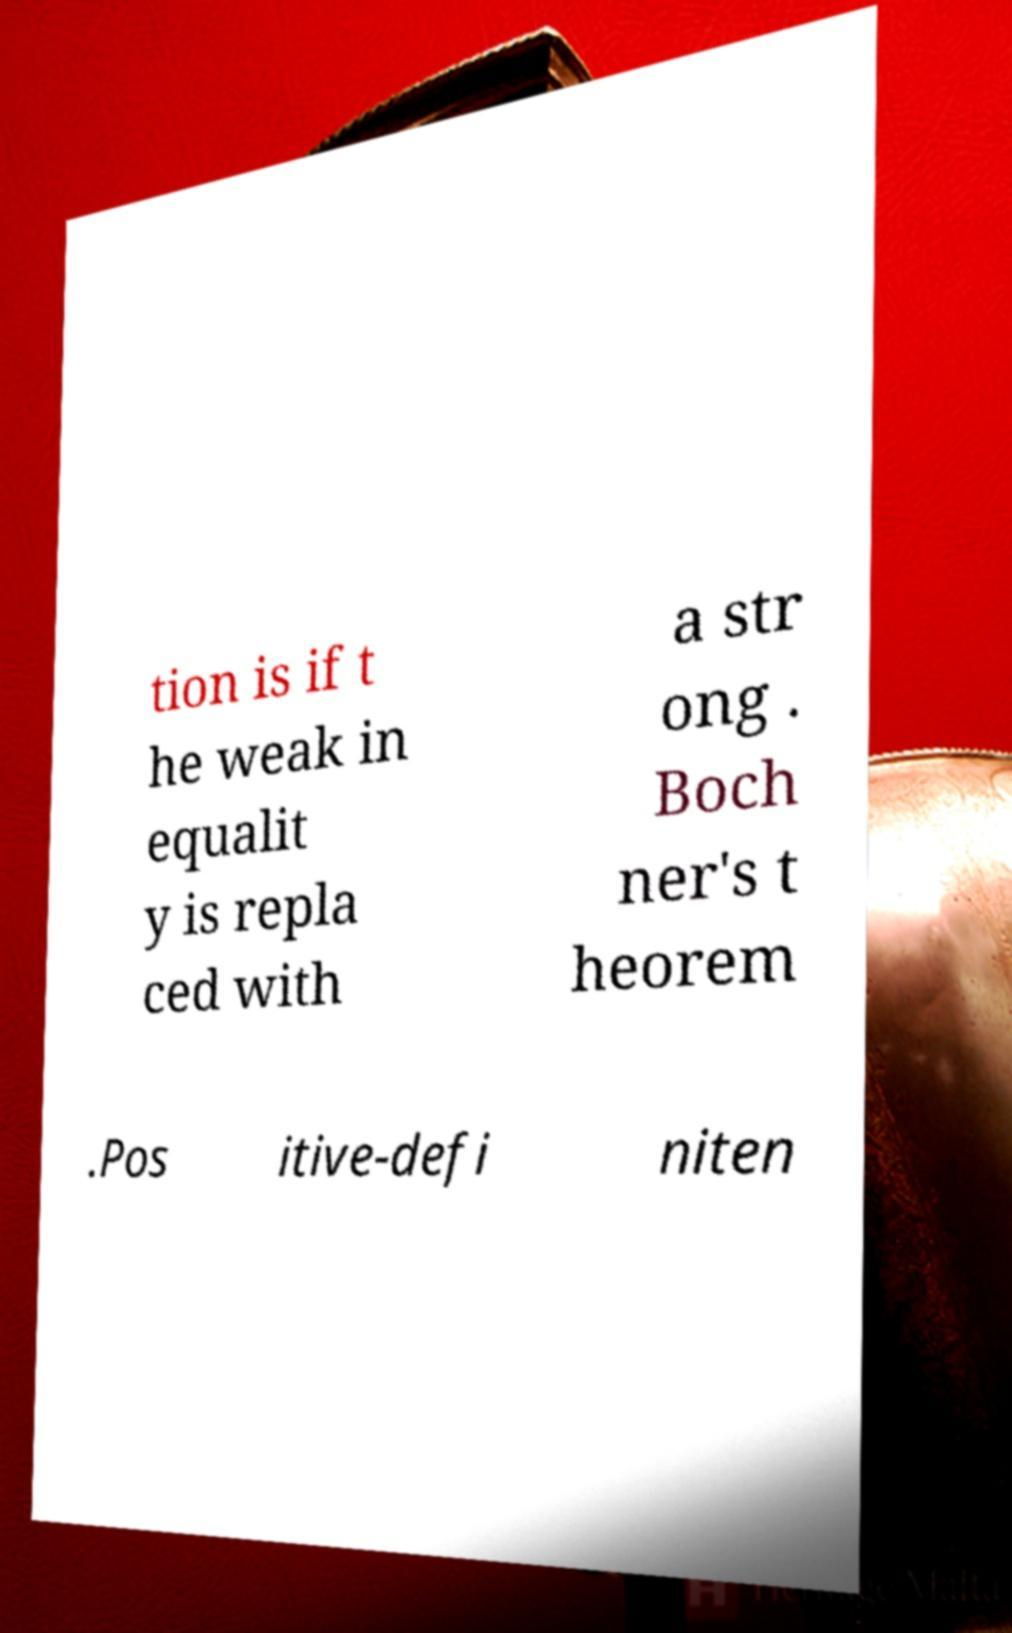Could you extract and type out the text from this image? tion is if t he weak in equalit y is repla ced with a str ong . Boch ner's t heorem .Pos itive-defi niten 